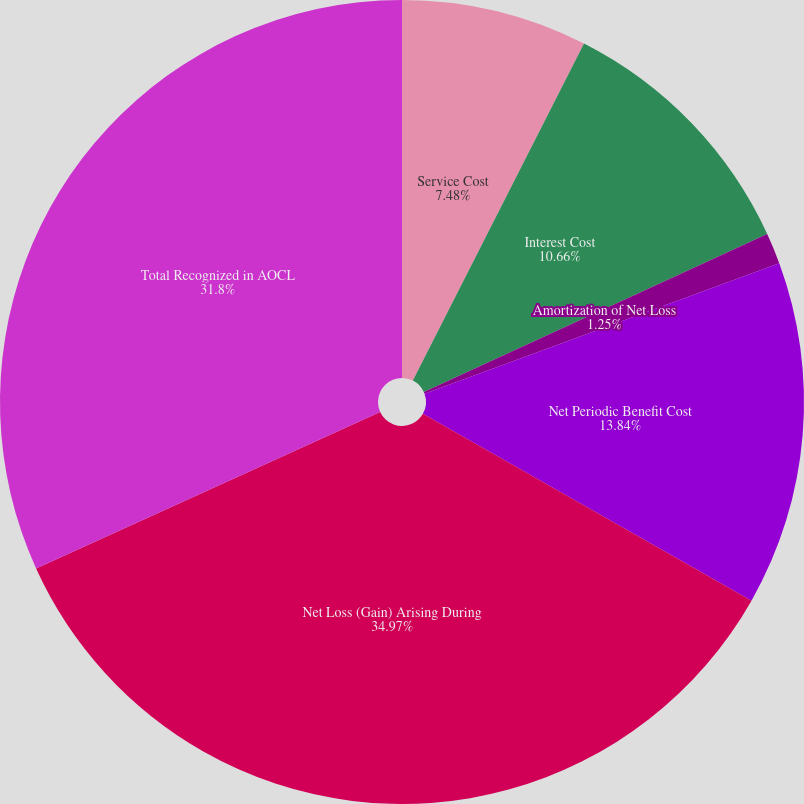<chart> <loc_0><loc_0><loc_500><loc_500><pie_chart><fcel>Service Cost<fcel>Interest Cost<fcel>Amortization of Net Loss<fcel>Net Periodic Benefit Cost<fcel>Net Loss (Gain) Arising During<fcel>Total Recognized in AOCL<nl><fcel>7.48%<fcel>10.66%<fcel>1.25%<fcel>13.84%<fcel>34.98%<fcel>31.8%<nl></chart> 